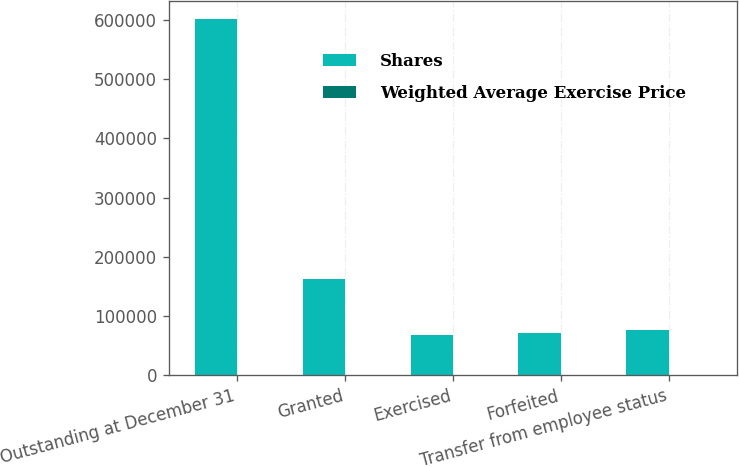<chart> <loc_0><loc_0><loc_500><loc_500><stacked_bar_chart><ecel><fcel>Outstanding at December 31<fcel>Granted<fcel>Exercised<fcel>Forfeited<fcel>Transfer from employee status<nl><fcel>Shares<fcel>601870<fcel>163159<fcel>68100<fcel>71116<fcel>77586<nl><fcel>Weighted Average Exercise Price<fcel>35.66<fcel>28.61<fcel>27.65<fcel>27.59<fcel>27.55<nl></chart> 